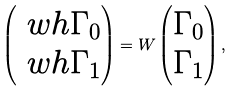<formula> <loc_0><loc_0><loc_500><loc_500>\begin{pmatrix} \ w h { \Gamma } _ { 0 } \\ \ w h { \Gamma } _ { 1 } \end{pmatrix} = W \begin{pmatrix} \Gamma _ { 0 } \\ \Gamma _ { 1 } \end{pmatrix} ,</formula> 